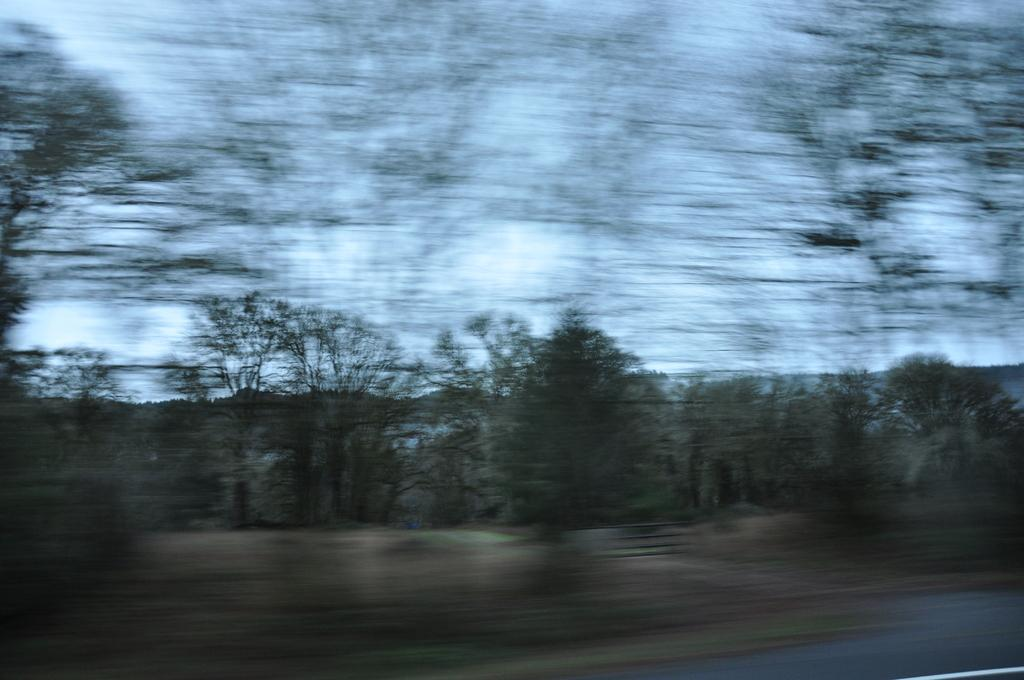What type of pathway is visible in the image? There is a road in the image. What natural elements can be seen in the image? There are trees and grass visible in the image. What part of the sky is visible in the image? The sky is visible in the image. From where might the image have been taken? The image appears to be taken from a roadside perspective. What type of stick can be seen smashing the popcorn in the image? There is no stick or popcorn present in the image. 